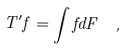<formula> <loc_0><loc_0><loc_500><loc_500>T ^ { \prime } f = \int f d F \ ,</formula> 